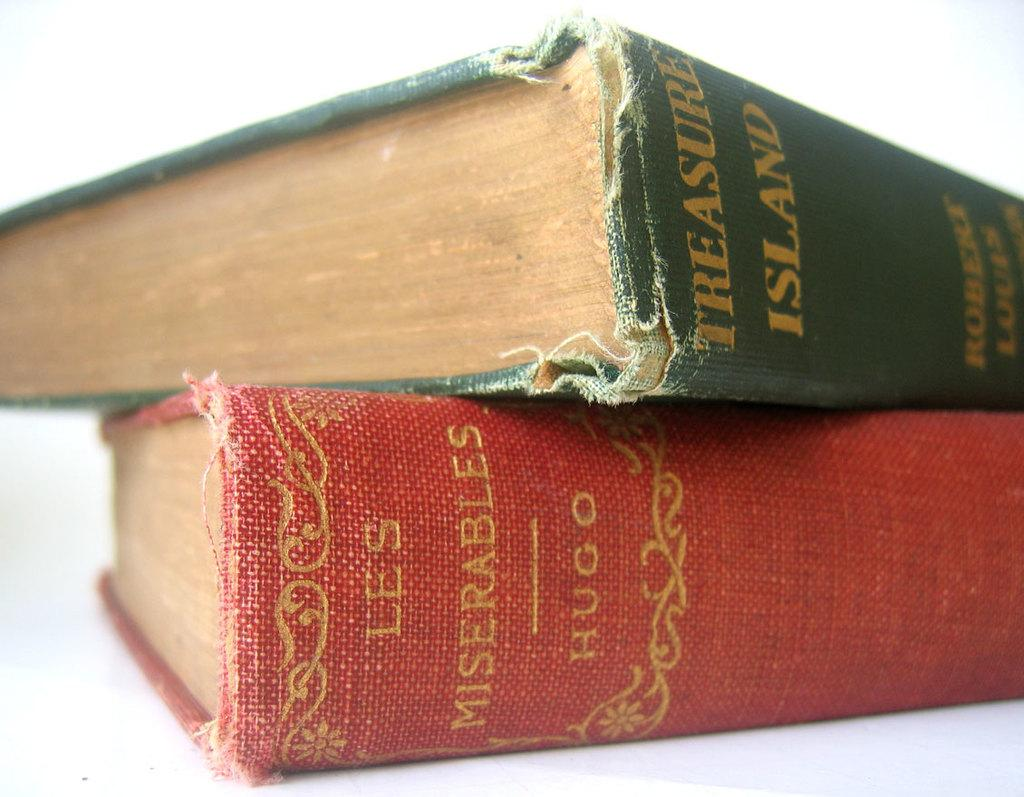How many books are visible in the image? There are two books in the image. What colors are the book covers? One book has a red color cover, and the other book has a green color cover. How are the books arranged in the image? The green color cover book is on top of the red color cover book. What type of meat is being cooked in the image? There is no meat or cooking activity present in the image; it only features two books with different colored covers. 